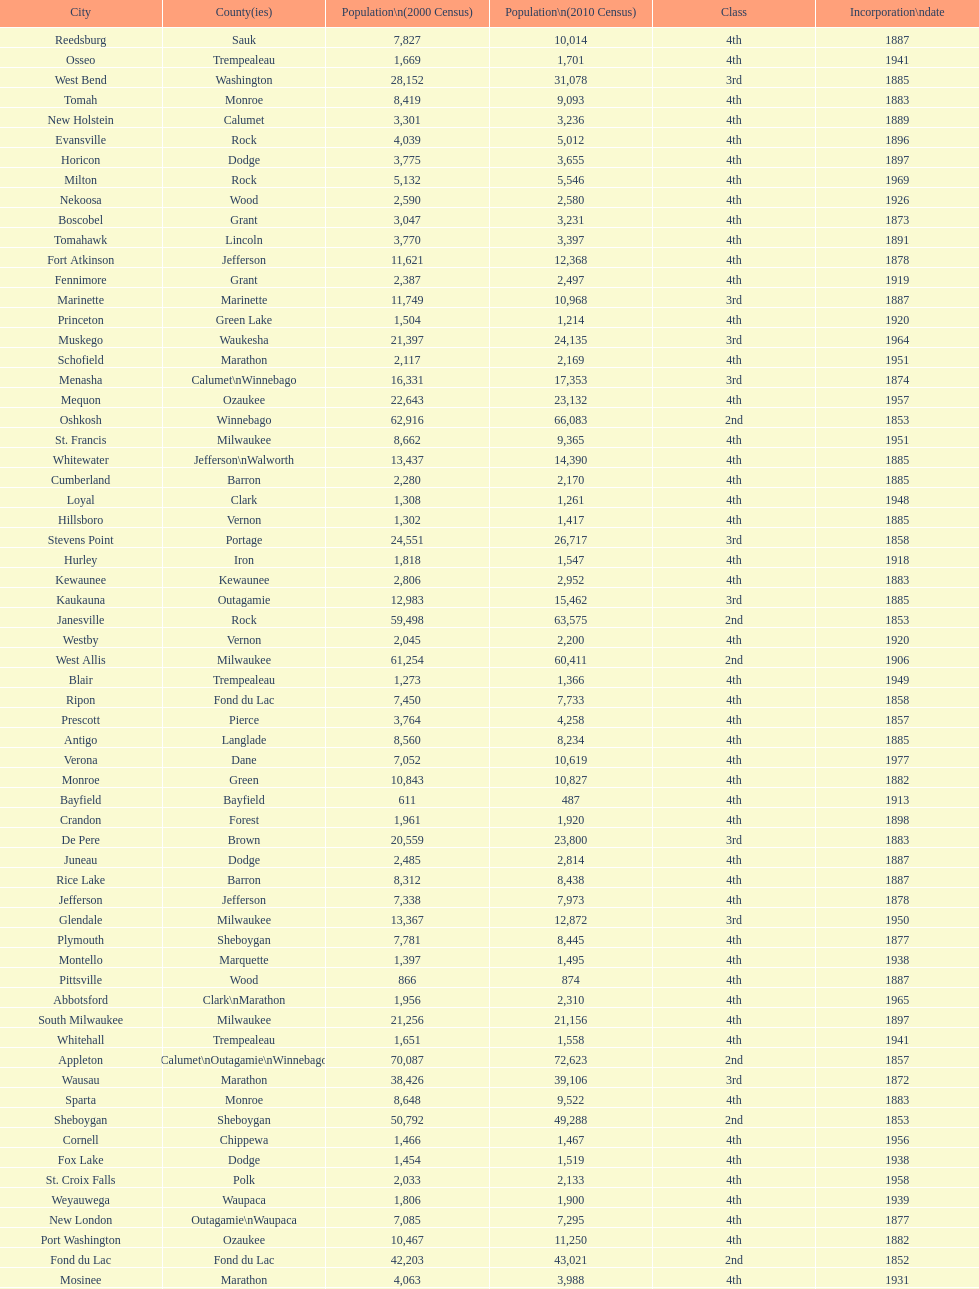Which city has the most population in the 2010 census? Milwaukee. 